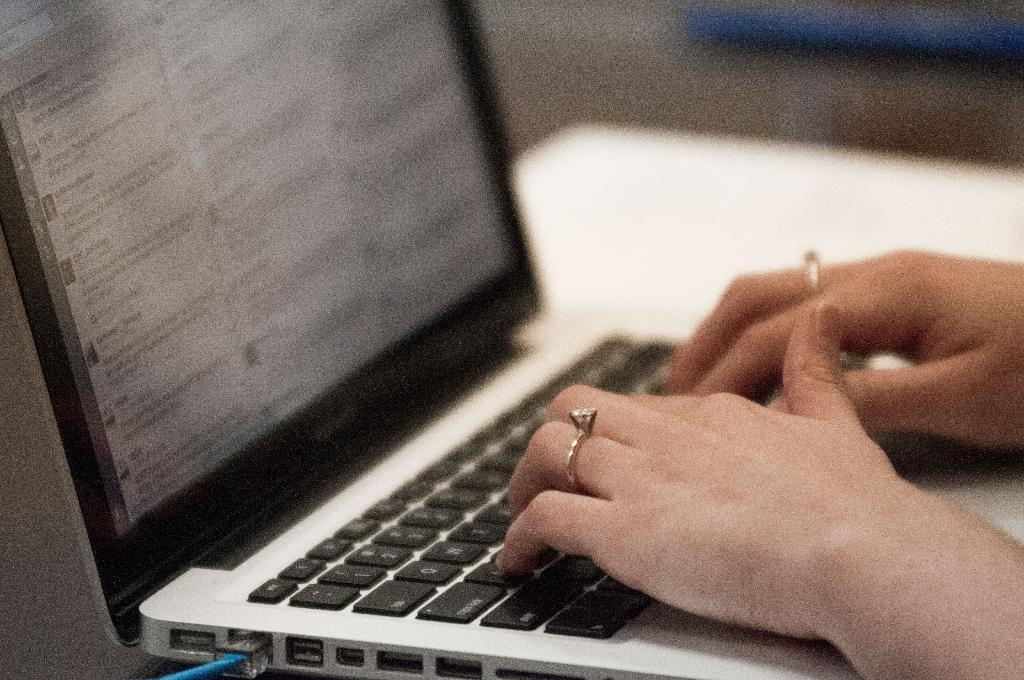<image>
Give a short and clear explanation of the subsequent image. a woman typing on a key board with CAPS LOCK key in front of wuzzed-out monitor 